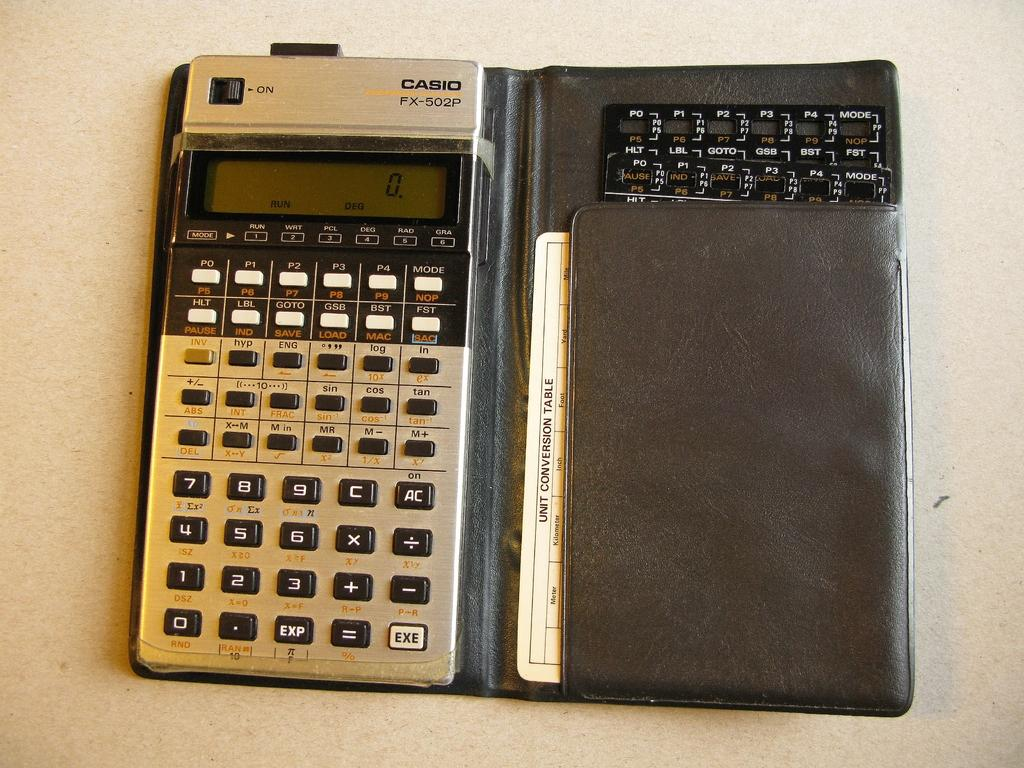What type of object is on the ground in the image? There is an electronic device on the ground in the image. What is the position of the card in relation to the electronic device? The card is in the image, but its exact position relative to the electronic device is not specified. What can be read on the card? The card has text on it. How does the electronic device kick the ball in the image? There is no ball present in the image, and the electronic device is not shown performing any actions, such as kicking. 